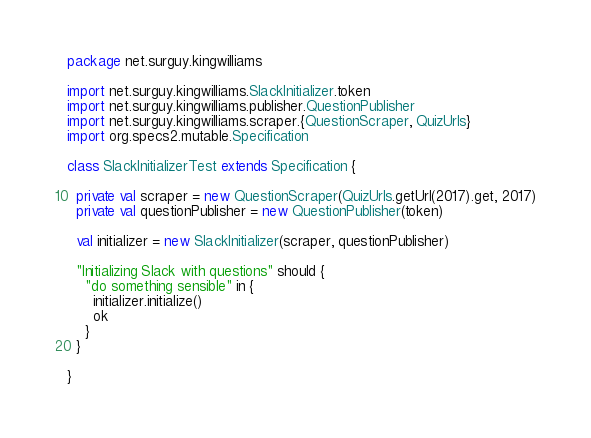Convert code to text. <code><loc_0><loc_0><loc_500><loc_500><_Scala_>package net.surguy.kingwilliams

import net.surguy.kingwilliams.SlackInitializer.token
import net.surguy.kingwilliams.publisher.QuestionPublisher
import net.surguy.kingwilliams.scraper.{QuestionScraper, QuizUrls}
import org.specs2.mutable.Specification

class SlackInitializerTest extends Specification {

  private val scraper = new QuestionScraper(QuizUrls.getUrl(2017).get, 2017)
  private val questionPublisher = new QuestionPublisher(token)

  val initializer = new SlackInitializer(scraper, questionPublisher)

  "Initializing Slack with questions" should {
    "do something sensible" in {
      initializer.initialize()
      ok
    }
  }

}
</code> 